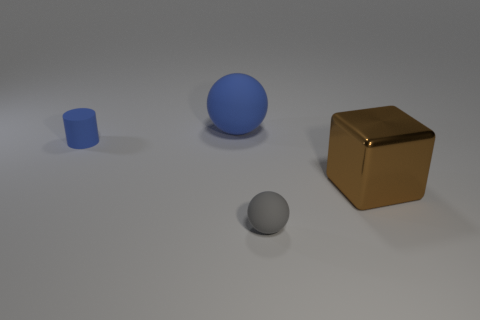Are there any other things that are made of the same material as the big brown object?
Provide a succinct answer. No. Is the color of the big block the same as the large rubber thing?
Provide a succinct answer. No. How many big objects are either purple blocks or cubes?
Make the answer very short. 1. Are there any other things that have the same color as the large rubber thing?
Your answer should be very brief. Yes. There is a small blue cylinder; are there any tiny rubber things behind it?
Give a very brief answer. No. There is a thing in front of the large object that is to the right of the small ball; what is its size?
Your answer should be very brief. Small. Is the number of tiny rubber objects that are on the right side of the tiny matte cylinder the same as the number of small gray balls to the left of the blue matte ball?
Ensure brevity in your answer.  No. Are there any tiny matte things that are in front of the large brown metallic block that is in front of the small blue rubber object?
Give a very brief answer. Yes. How many matte cylinders are left of the rubber sphere behind the small rubber thing left of the gray rubber thing?
Give a very brief answer. 1. Is the number of green rubber cylinders less than the number of matte balls?
Give a very brief answer. Yes. 